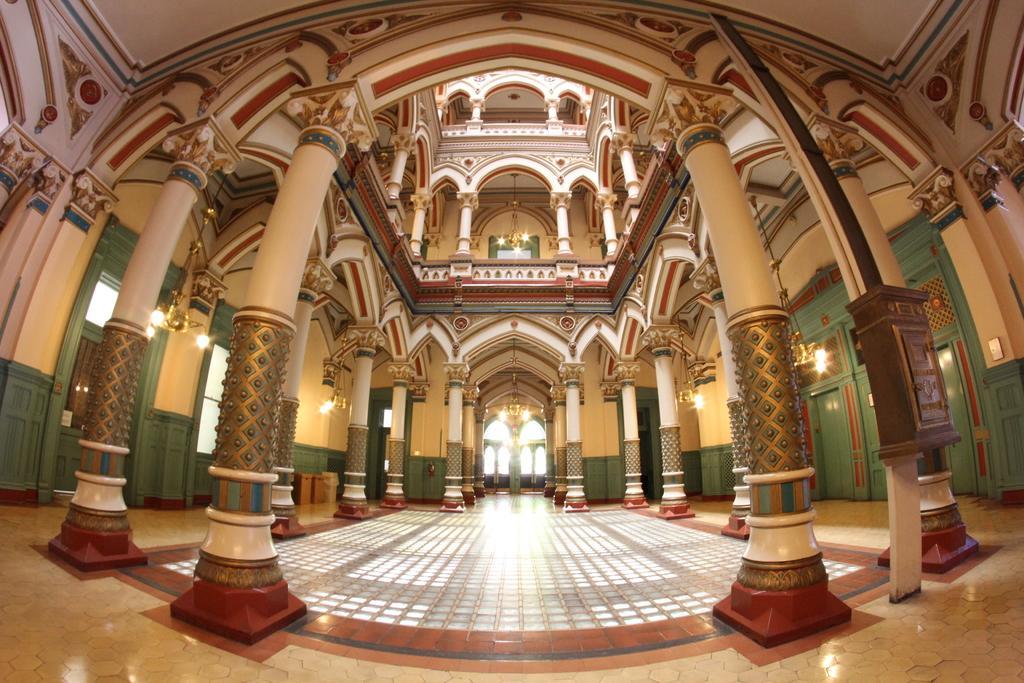In one or two sentences, can you explain what this image depicts? This picture is clicked inside the hall. In this picture, we see many pillars in white color. On the right side, we see doors in green color and the lights. On the left side, we see green color doors and we even see the lights. At the top of the picture, we see the chandelier. 